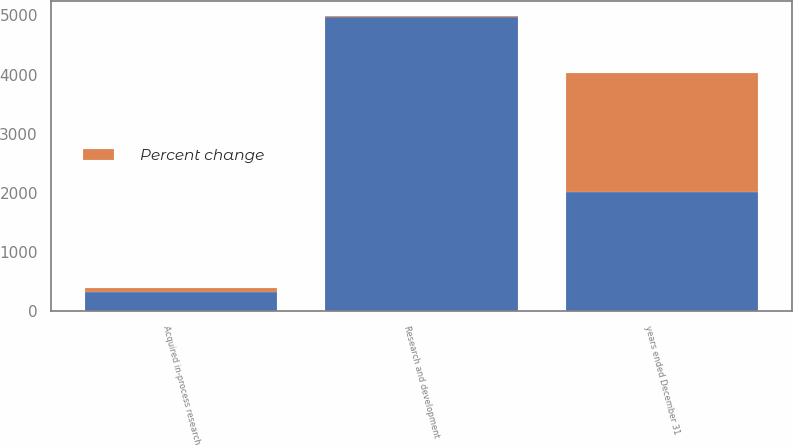<chart> <loc_0><loc_0><loc_500><loc_500><stacked_bar_chart><ecel><fcel>years ended December 31<fcel>Research and development<fcel>Acquired in-process research<nl><fcel>nan<fcel>2017<fcel>4982<fcel>327<nl><fcel>Percent change<fcel>2017<fcel>14<fcel>64<nl></chart> 